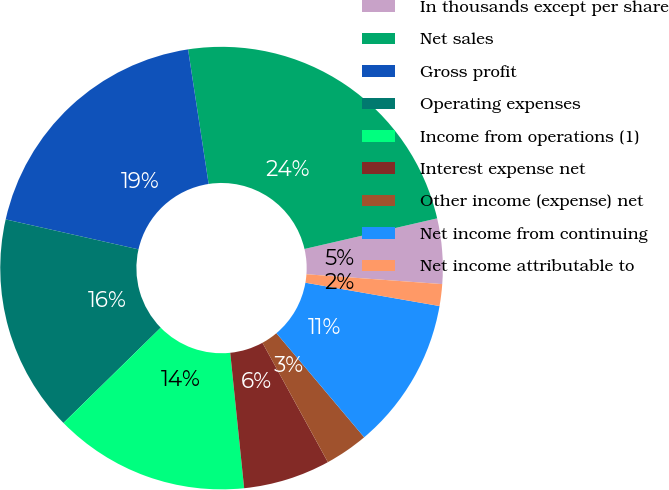Convert chart to OTSL. <chart><loc_0><loc_0><loc_500><loc_500><pie_chart><fcel>In thousands except per share<fcel>Net sales<fcel>Gross profit<fcel>Operating expenses<fcel>Income from operations (1)<fcel>Interest expense net<fcel>Other income (expense) net<fcel>Net income from continuing<fcel>Net income attributable to<nl><fcel>4.76%<fcel>23.81%<fcel>19.05%<fcel>15.87%<fcel>14.29%<fcel>6.35%<fcel>3.17%<fcel>11.11%<fcel>1.59%<nl></chart> 